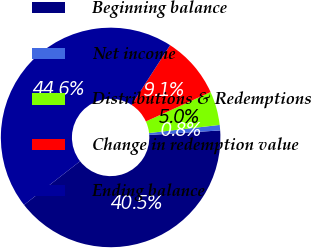Convert chart to OTSL. <chart><loc_0><loc_0><loc_500><loc_500><pie_chart><fcel>Beginning balance<fcel>Net income<fcel>Distributions & Redemptions<fcel>Change in redemption value<fcel>Ending balance<nl><fcel>40.49%<fcel>0.8%<fcel>4.96%<fcel>9.11%<fcel>44.64%<nl></chart> 